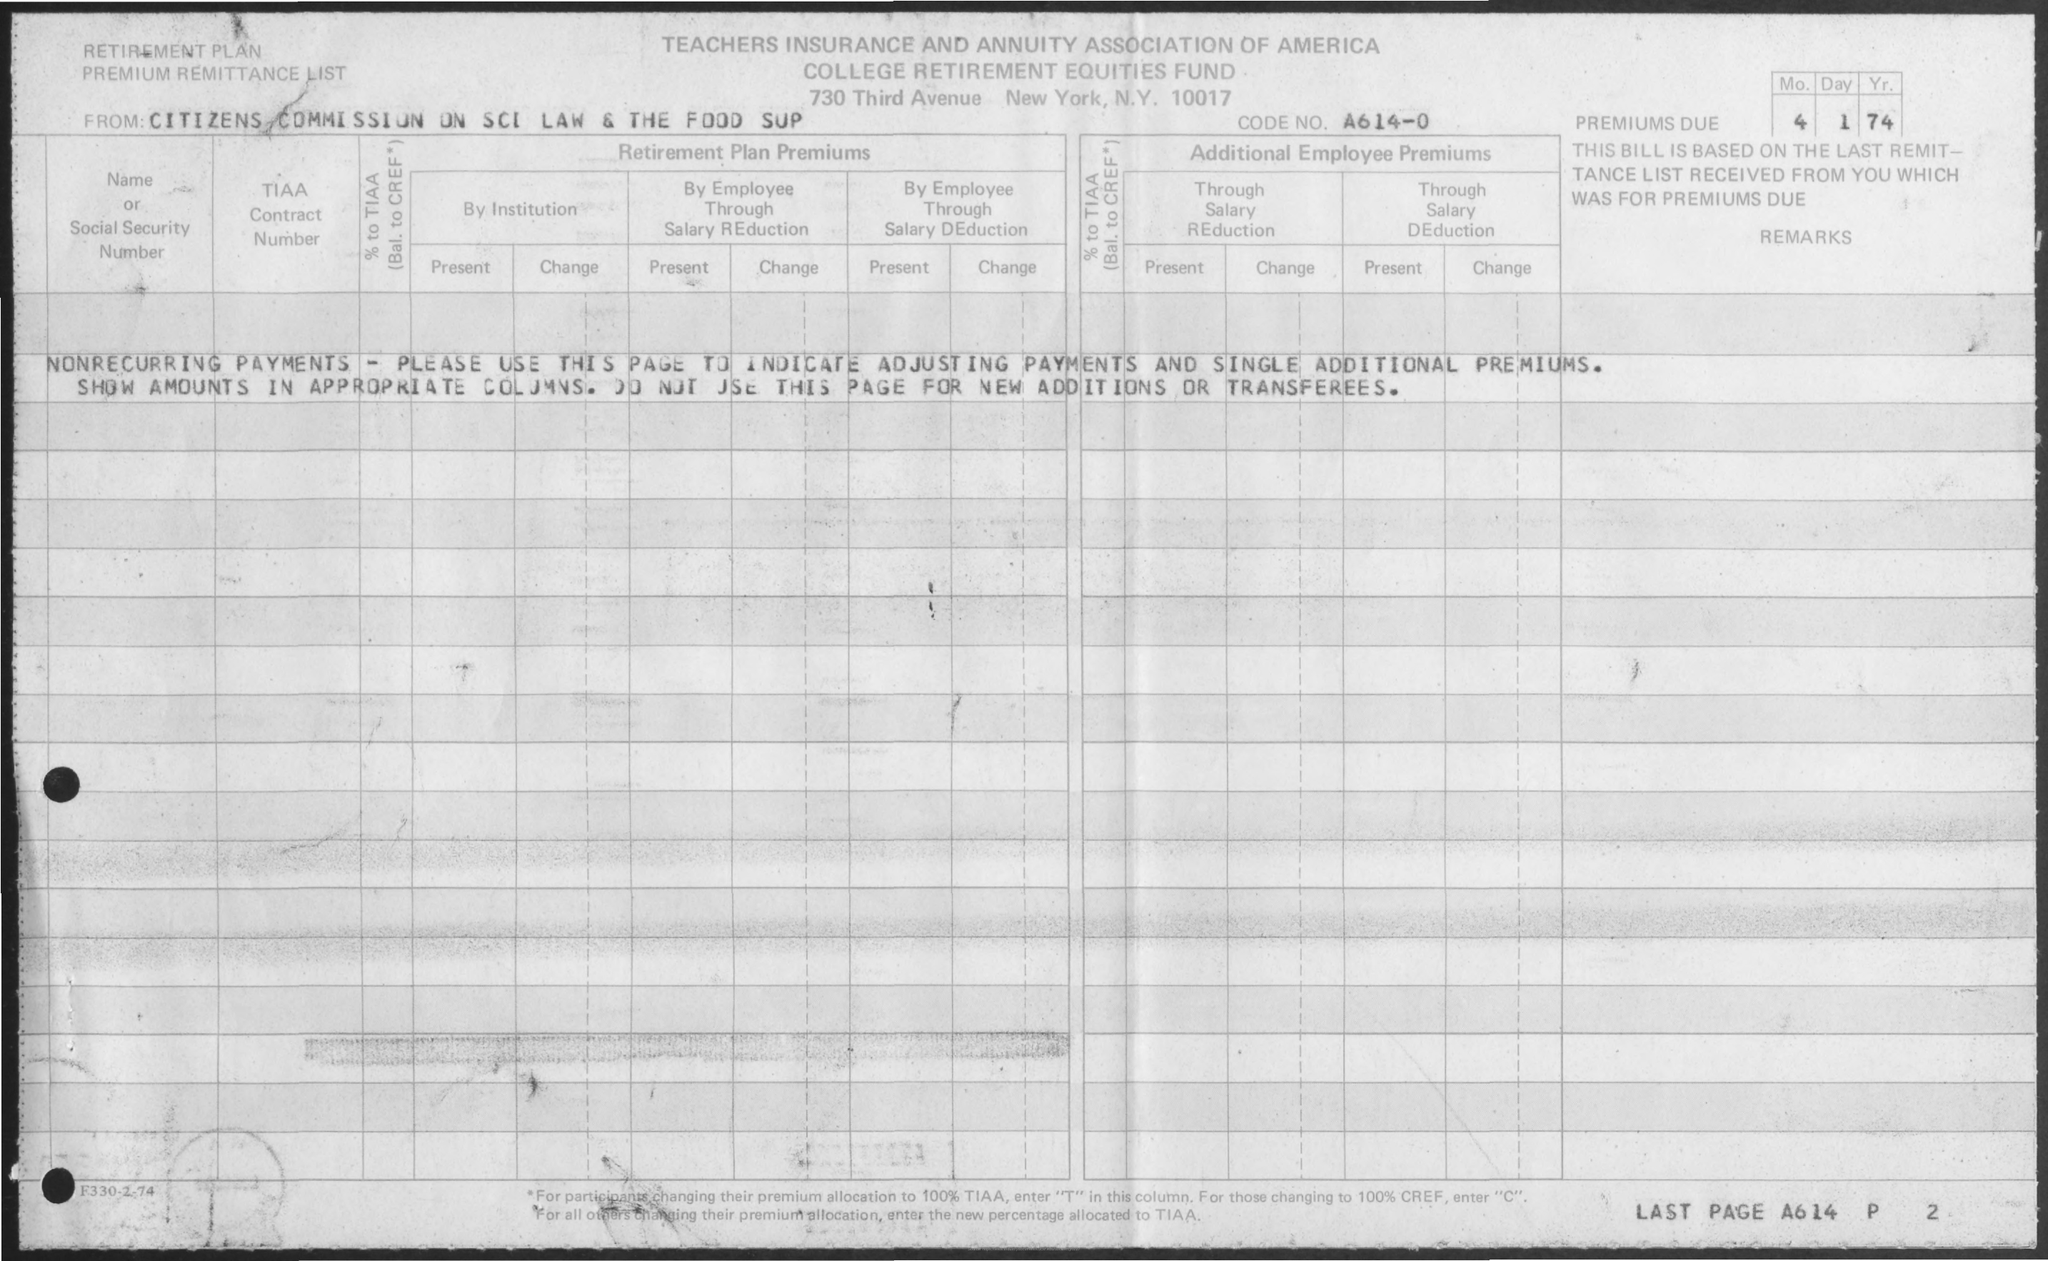List a handful of essential elements in this visual. The premium is due on January 4, 2021. 